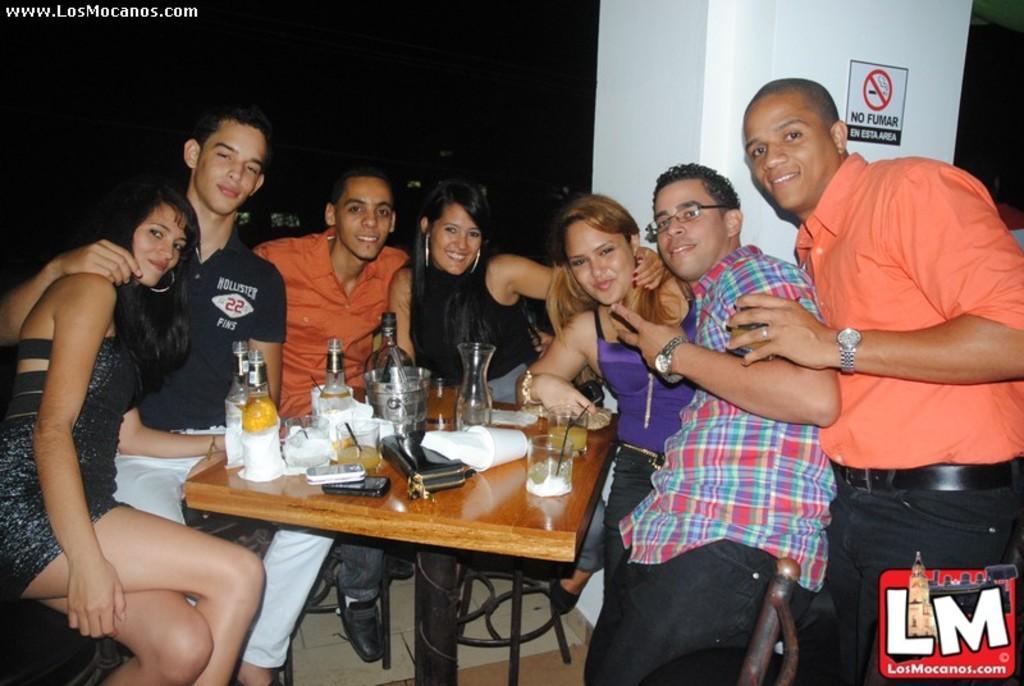Please provide a concise description of this image. In this picture we can see some persons are sitting on the chairs. This is table. On the table there are bottles, glasses, and mobiles. On the background there is a wall. And this is board. 